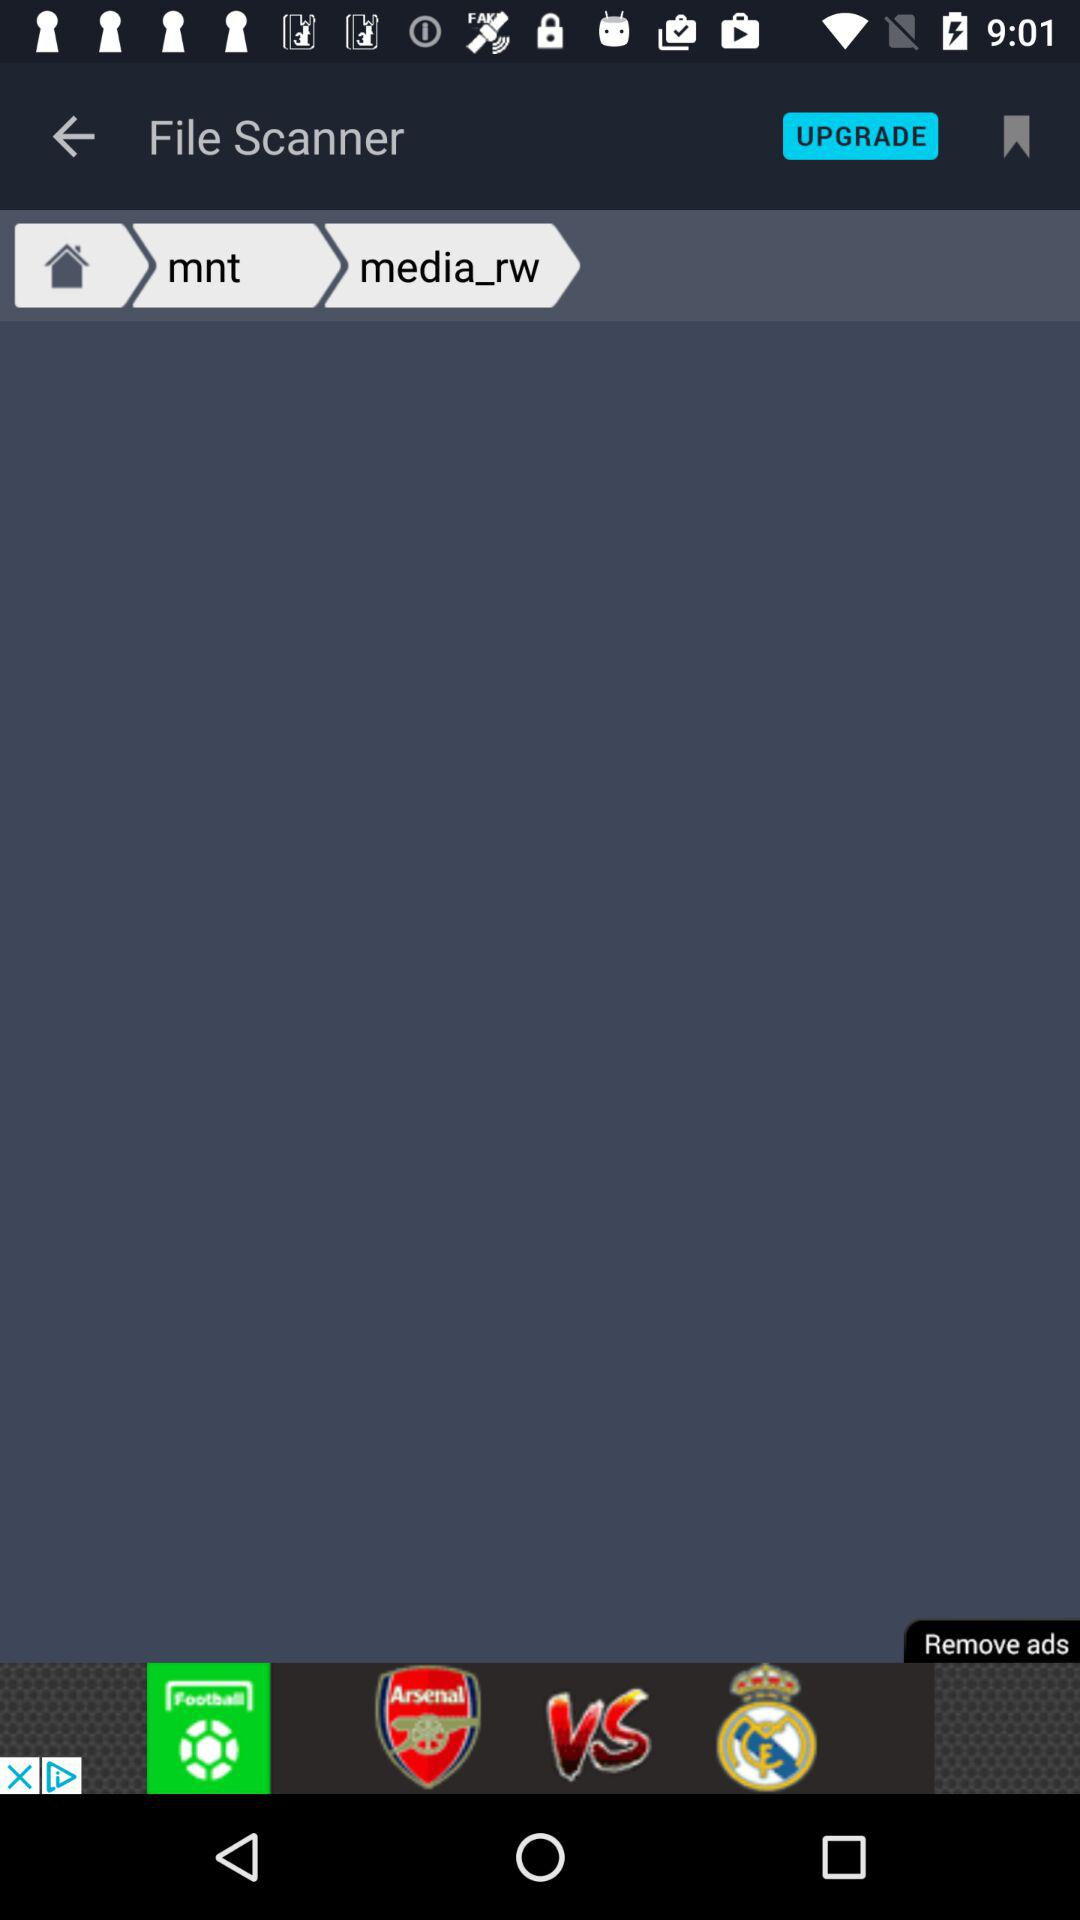What is the application name? The application name is "File Scanner". 